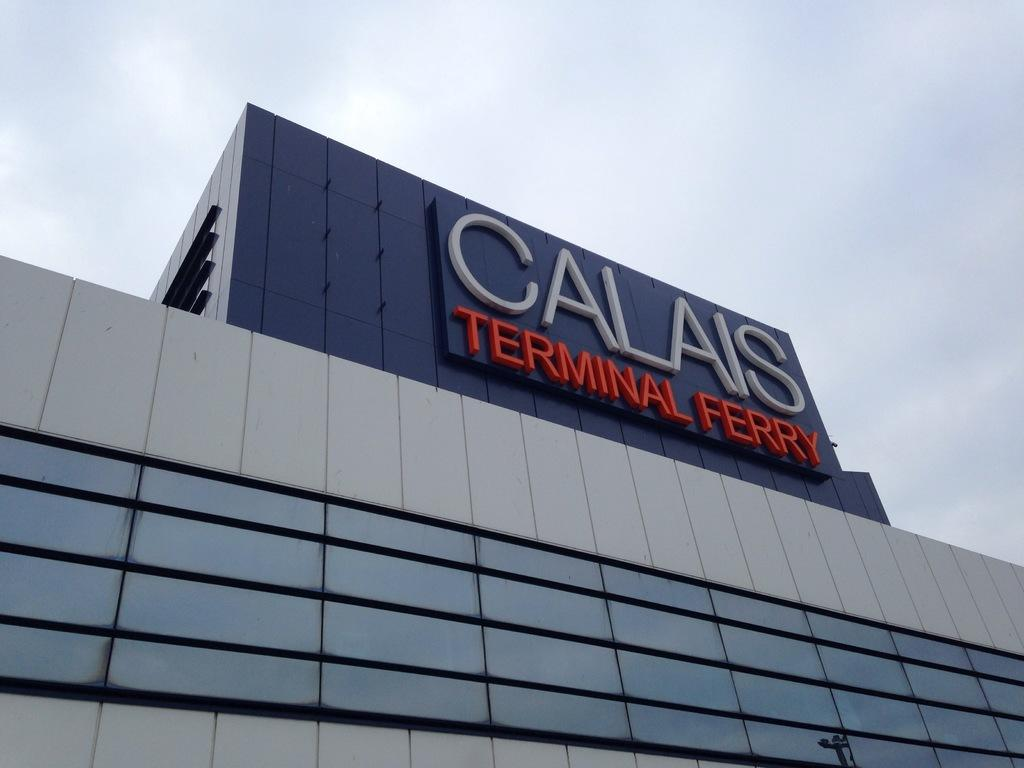What type of structure is present in the image? There is a building in the image. What part of the natural environment can be seen in the image? The sky is visible in the image. How many twigs are being copied in the image? There are no twigs present in the image. What type of bit is being used to interact with the building in the image? There is no bit present in the image, and the building is not being interacted with in any way. 